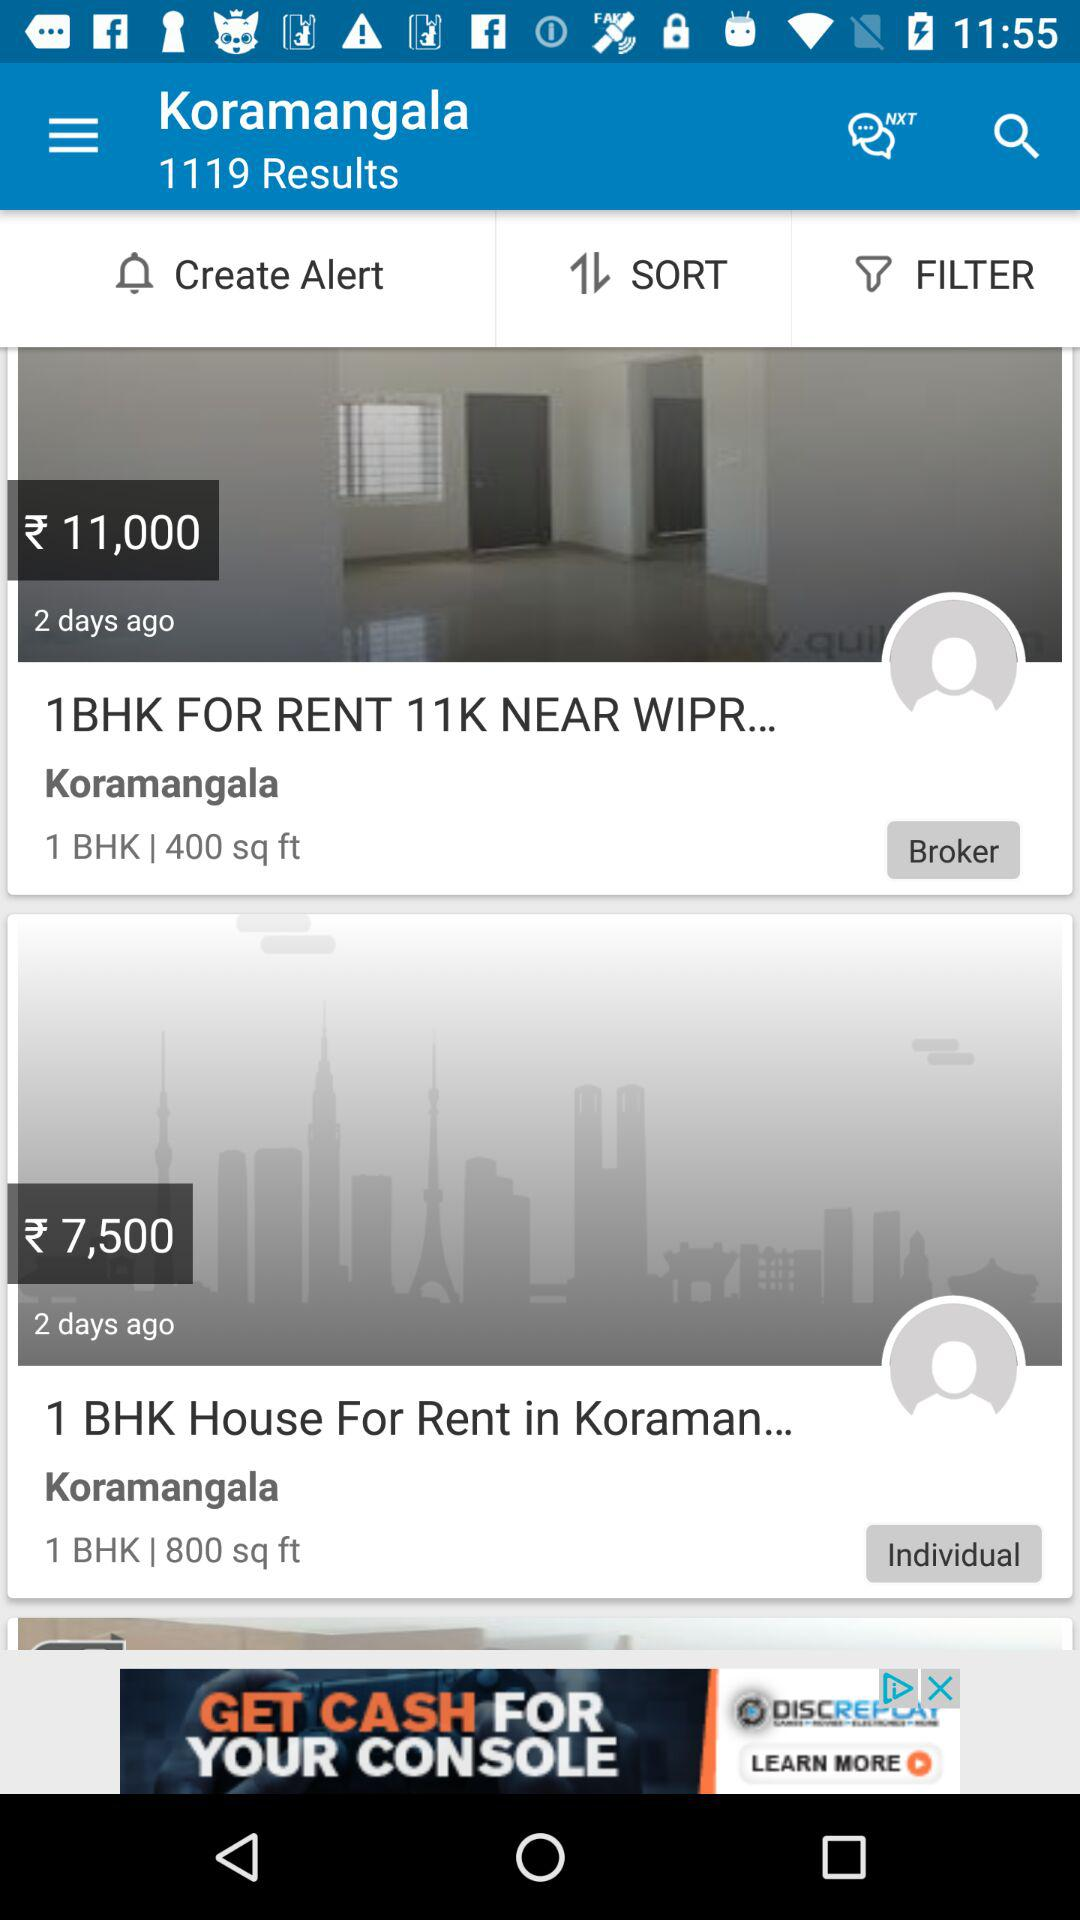What is the flat size whose rent is ₹11000? The flat size is 400 sq ft. 